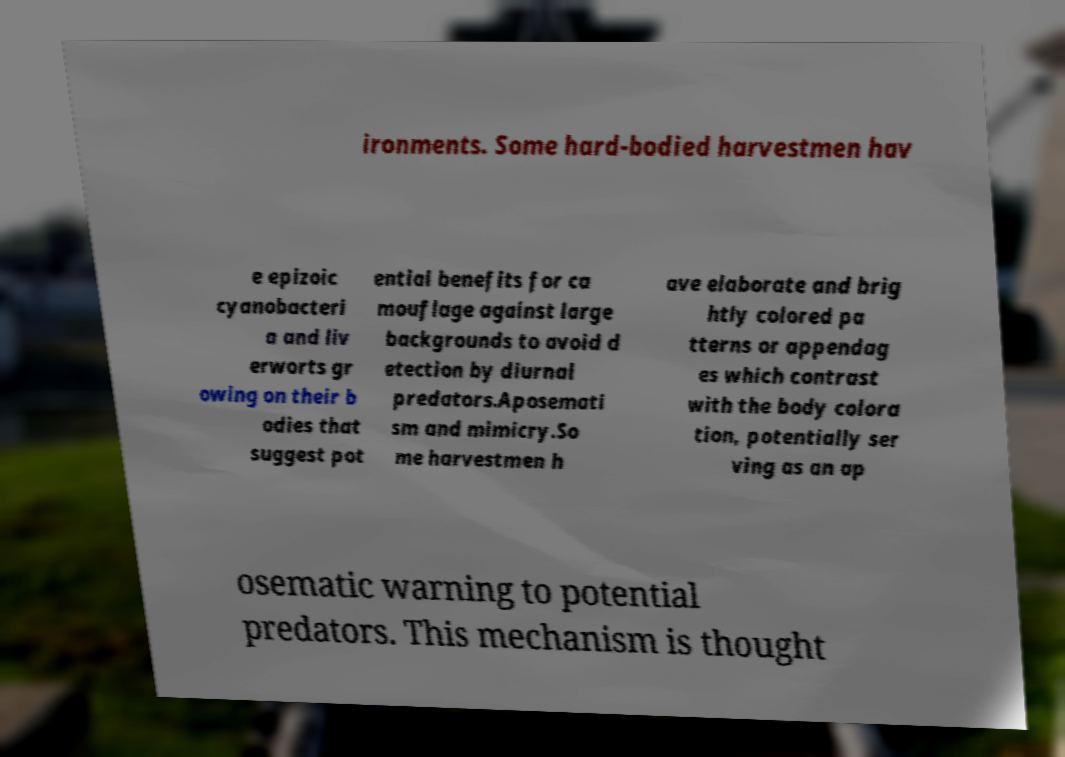Could you extract and type out the text from this image? ironments. Some hard-bodied harvestmen hav e epizoic cyanobacteri a and liv erworts gr owing on their b odies that suggest pot ential benefits for ca mouflage against large backgrounds to avoid d etection by diurnal predators.Aposemati sm and mimicry.So me harvestmen h ave elaborate and brig htly colored pa tterns or appendag es which contrast with the body colora tion, potentially ser ving as an ap osematic warning to potential predators. This mechanism is thought 